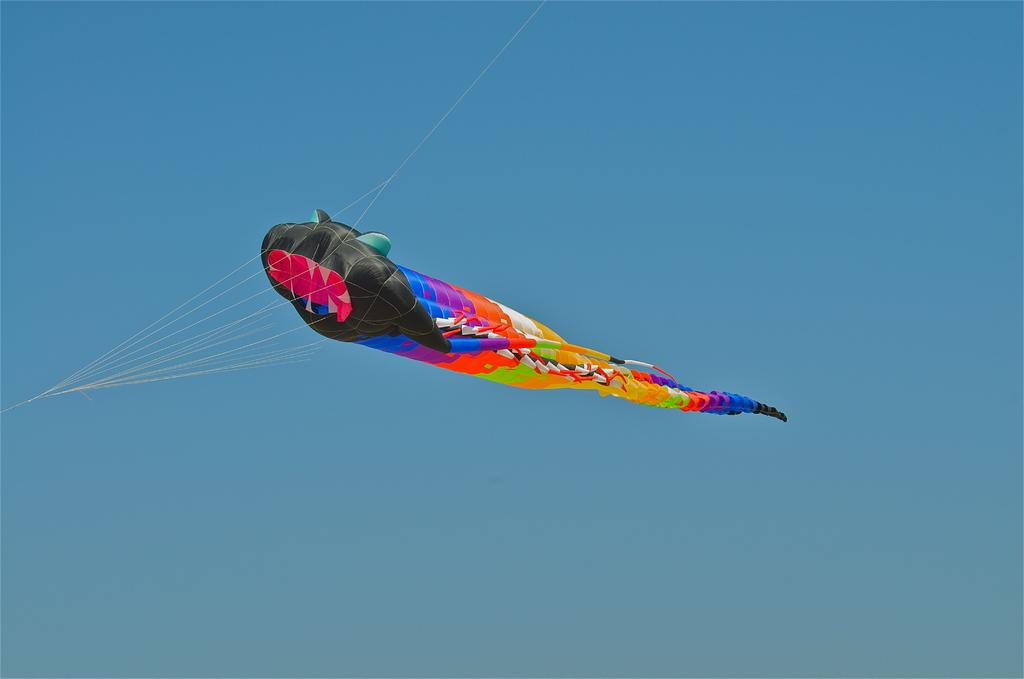What object can be seen in the image that is flying in the air? There is a colorful kite in the image that is flying in the air. How is the kite being controlled in the air? The kite has ropes attached to it, which are likely being held by someone on the ground. What can be seen in the background of the image? The sky is visible in the background of the image. What type of beast is depicted in the image? There is no beast present in the image; it features a colorful kite flying in the air. What religious symbol can be seen in the image? There is no religious symbol present in the image; it features a colorful kite flying in the air with ropes attached to it. 